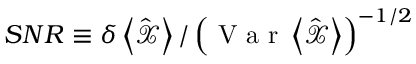Convert formula to latex. <formula><loc_0><loc_0><loc_500><loc_500>S N R \equiv \delta \left < \hat { \mathcal { X } } \right > / \left ( V a r \left < \hat { \mathcal { X } } \right > \right ) ^ { - 1 / 2 }</formula> 